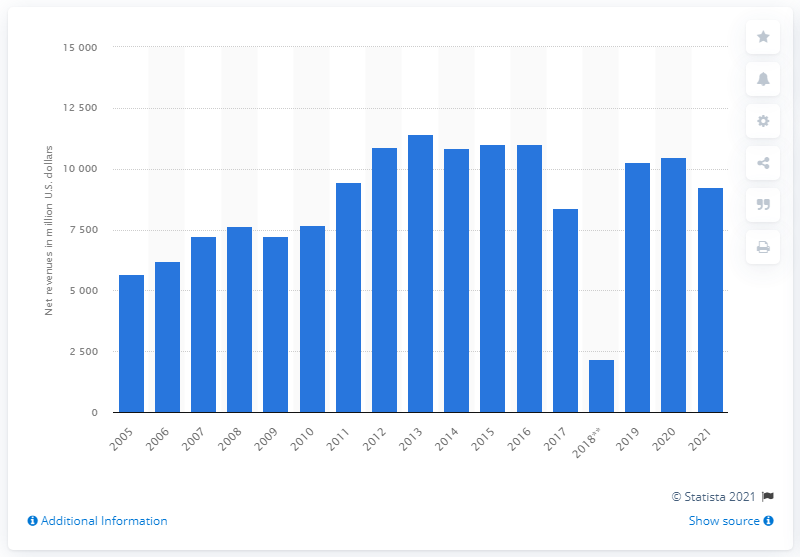Give some essential details in this illustration. In 2021, VF Corporation's total revenues were 9,238.83. 